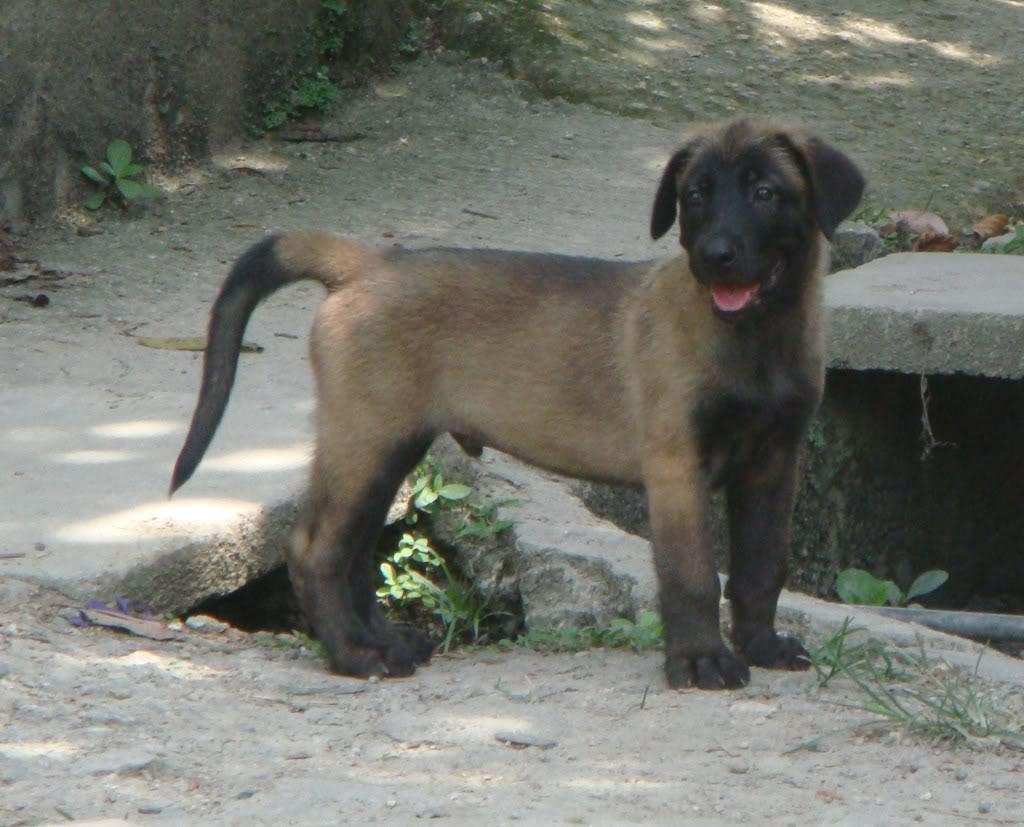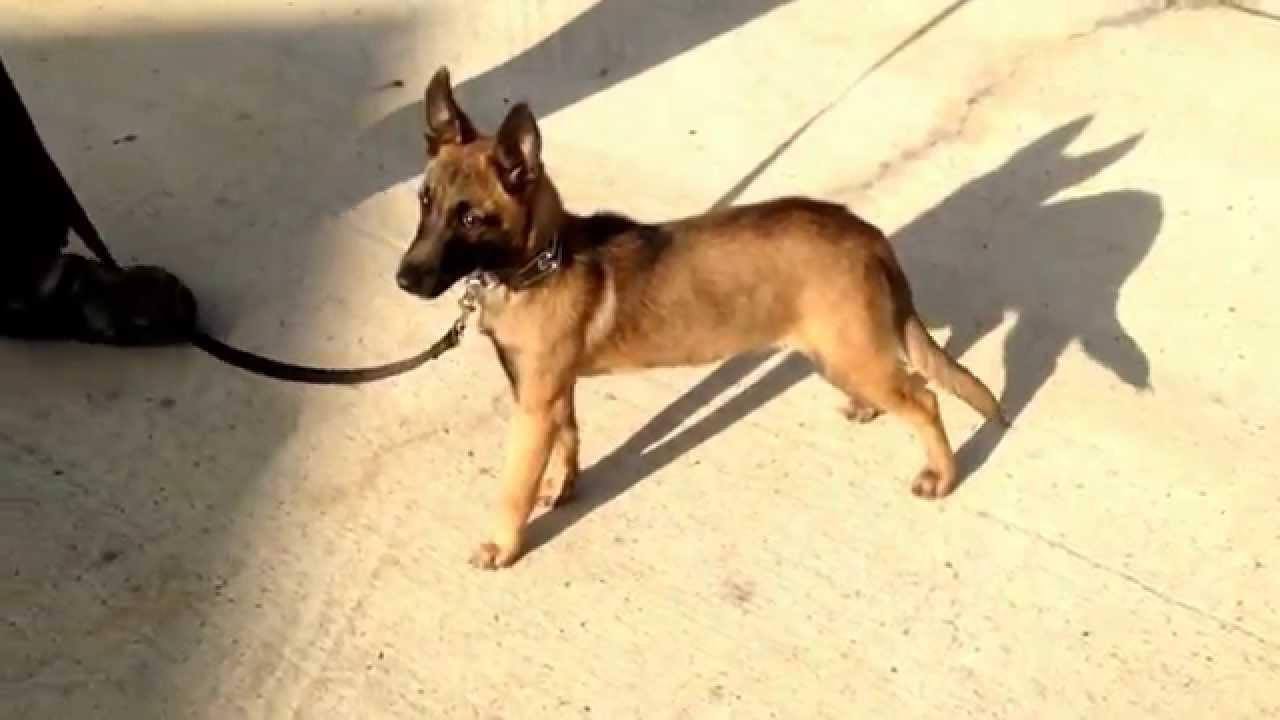The first image is the image on the left, the second image is the image on the right. For the images displayed, is the sentence "The left image contains two dogs." factually correct? Answer yes or no. No. The first image is the image on the left, the second image is the image on the right. Evaluate the accuracy of this statement regarding the images: "The righthand image contains exactly one dog, which is sitting upright with its body turned to the camera.". Is it true? Answer yes or no. No. 